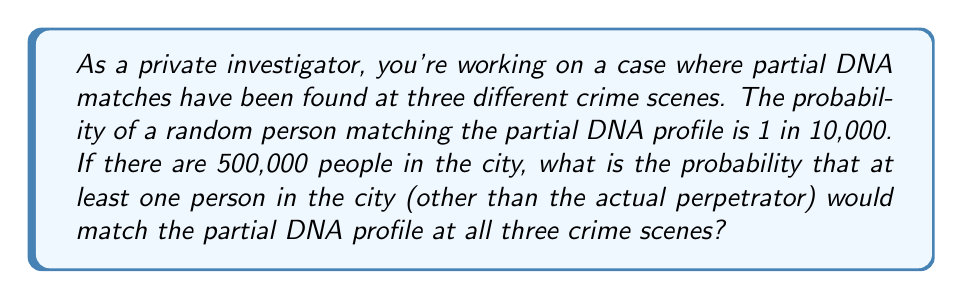Give your solution to this math problem. Let's approach this step-by-step:

1) First, we need to calculate the probability of a single person matching the DNA profile at all three crime scenes:

   $P(\text{match all three}) = (\frac{1}{10000})^3 = 10^{-12}$

2) Now, we want to find the probability that at least one person in the city (excluding the perpetrator) matches. It's easier to calculate the probability that no one matches and then subtract from 1.

3) The probability that a single person doesn't match all three is:

   $P(\text{not match all three}) = 1 - 10^{-12}$

4) For all 500,000 people to not match, we raise this to the power of 500,000:

   $P(\text{no one matches}) = (1 - 10^{-12})^{500000}$

5) We can simplify this using the binomial approximation $(1-x)^n \approx 1-nx$ when $x$ is very small:

   $P(\text{no one matches}) \approx 1 - 500000 \cdot 10^{-12} = 1 - 5 \cdot 10^{-7}$

6) Therefore, the probability that at least one person matches is:

   $P(\text{at least one matches}) = 1 - P(\text{no one matches})$
   $= 1 - (1 - 5 \cdot 10^{-7}) = 5 \cdot 10^{-7}$

This is approximately 0.0000005 or 0.00005%.
Answer: $5 \cdot 10^{-7}$ 